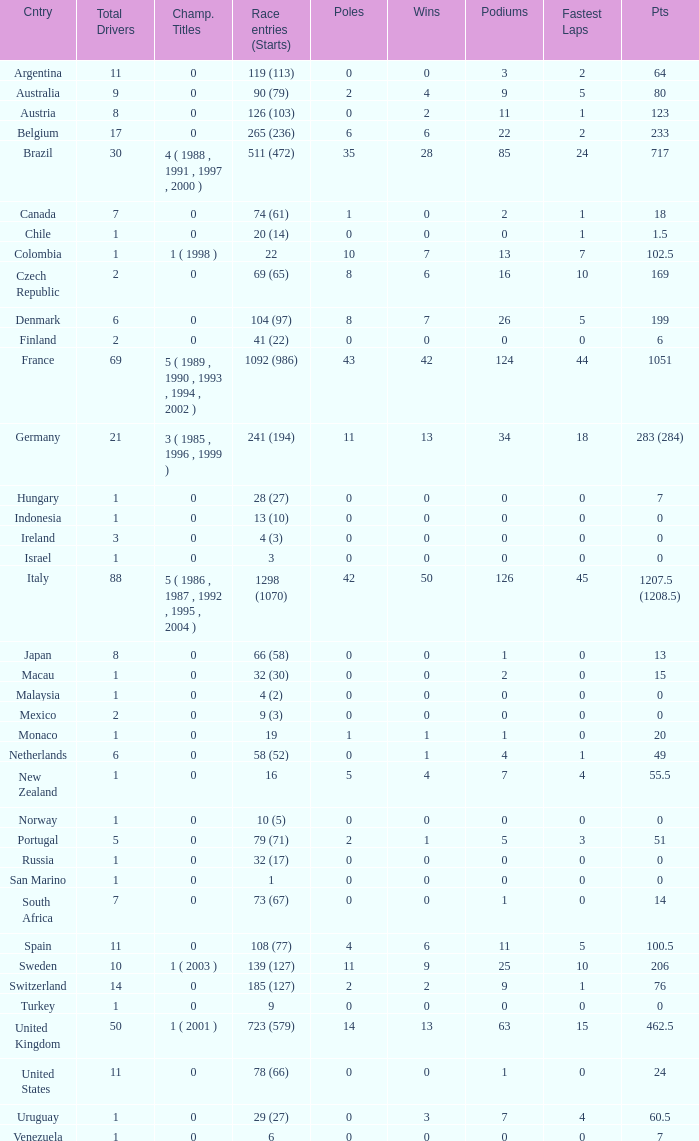How many fastest laps for the nation with 32 (30) entries and starts and fewer than 2 podiums? None. 